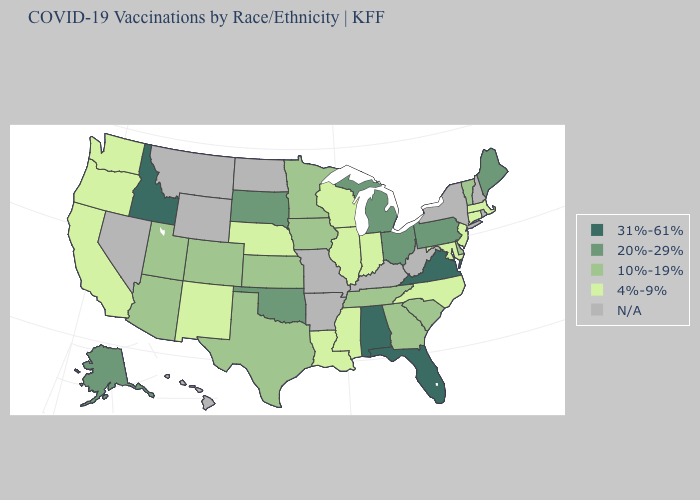Which states have the lowest value in the USA?
Answer briefly. California, Connecticut, Illinois, Indiana, Louisiana, Maryland, Massachusetts, Mississippi, Nebraska, New Jersey, New Mexico, North Carolina, Oregon, Washington, Wisconsin. Does the map have missing data?
Give a very brief answer. Yes. Which states have the lowest value in the USA?
Be succinct. California, Connecticut, Illinois, Indiana, Louisiana, Maryland, Massachusetts, Mississippi, Nebraska, New Jersey, New Mexico, North Carolina, Oregon, Washington, Wisconsin. What is the value of Kentucky?
Quick response, please. N/A. Among the states that border Delaware , does Pennsylvania have the lowest value?
Answer briefly. No. Which states have the lowest value in the USA?
Concise answer only. California, Connecticut, Illinois, Indiana, Louisiana, Maryland, Massachusetts, Mississippi, Nebraska, New Jersey, New Mexico, North Carolina, Oregon, Washington, Wisconsin. Name the states that have a value in the range N/A?
Be succinct. Arkansas, Hawaii, Kentucky, Missouri, Montana, Nevada, New Hampshire, New York, North Dakota, Rhode Island, West Virginia, Wyoming. Which states have the highest value in the USA?
Be succinct. Alabama, Florida, Idaho, Virginia. What is the value of Ohio?
Keep it brief. 20%-29%. What is the value of Texas?
Short answer required. 10%-19%. What is the value of New Mexico?
Give a very brief answer. 4%-9%. What is the value of Kansas?
Give a very brief answer. 10%-19%. Which states have the lowest value in the USA?
Answer briefly. California, Connecticut, Illinois, Indiana, Louisiana, Maryland, Massachusetts, Mississippi, Nebraska, New Jersey, New Mexico, North Carolina, Oregon, Washington, Wisconsin. What is the lowest value in the USA?
Be succinct. 4%-9%. Does Nebraska have the lowest value in the USA?
Answer briefly. Yes. 